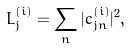<formula> <loc_0><loc_0><loc_500><loc_500>L _ { j } ^ { ( i ) } = \sum _ { n } | c _ { j n } ^ { ( i ) } | ^ { 2 } ,</formula> 